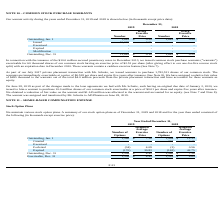According to Acura Pharmaceuticals's financial document, How many common shares were purchased in July 2017? As part of our July 2017 private placement transaction with Mr. Schutte, we issued warrants to purchase 1,782,531 shares of our common stock.. The document states: "contain a cashless exercise feature (See Note 7). As part of our July 2017 private placement transaction with Mr. Schutte, we issued warrants to purch..." Also, What was the exercise price of that 10 million common stock for Mr. Schutte in 2019 On June 28, 2019 as part of the changes made to the loan agreements we had with Mr. Schutte, each having an original due date of January 2, 2020, we issued to him a warrant to purchase 10.0 million shares of our common stock exercisable at a price of $0.01 per share and expire five years after issuance.. The document states: "n and have accounted for these warrants as equity. On June 28, 2019 as part of the changes made to the loan agreements we had with Mr. Schutte, each h..." Also, What was the expiration date of the 10 million secured promissory notes issued in December 2013?  In connection with the issuance of the $10.0 million secured promissory notes in December 2013, we issued common stock purchase warrants (“warrants”) exercisable for 60 thousand shares of our common stock having an exercise price of $2.52 per share (after giving effect to our one-for-five reverse stock split) with an expiration date in December 2020.. The document states: "In connection with the issuance of the $10.0 million secured promissory notes in December 2013, we issued common stock purchase warrants (“warrants”) ..." Also, can you calculate: What is the difference between the ending outstanding common stock purchase warrants in 2018 and 2019?  Based on the calculation: 0.59 - 0.1 , the result is 0.49. This is based on the information: "Outstanding, Jan. 1 1,842 $ 0.59 1,842 $ 0.59 Outstanding, Dec. 31 11,842 $ 0.10 1,842 $ 0.59..." The key data points involved are: 0.1, 0.59. Also, can you calculate: What is the percentage increase in ending outstanding common stock purchase warrants from 2018 to 2019? Based on the calculation: 10,000 / 1,842 , the result is 542.89 (percentage). This is based on the information: "Issued 10,000 0.01 - - Outstanding, Jan. 1 1,842 $ 0.59 1,842 $ 0.59..." The key data points involved are: 1,842, 10,000. Also, can you calculate: How much was the percentage decrease in ending price of outstanding common stock purchase warrants from 2018 to 2019? To answer this question, I need to perform calculations using the financial data. The calculation is: (0.59 - 0.10) / 0.59 , which equals 83.05 (percentage). This is based on the information: "Outstanding, Dec. 31 11,842 $ 0.10 1,842 $ 0.59 Outstanding, Jan. 1 1,842 $ 0.59 1,842 $ 0.59..." The key data points involved are: 0.10, 0.59. 